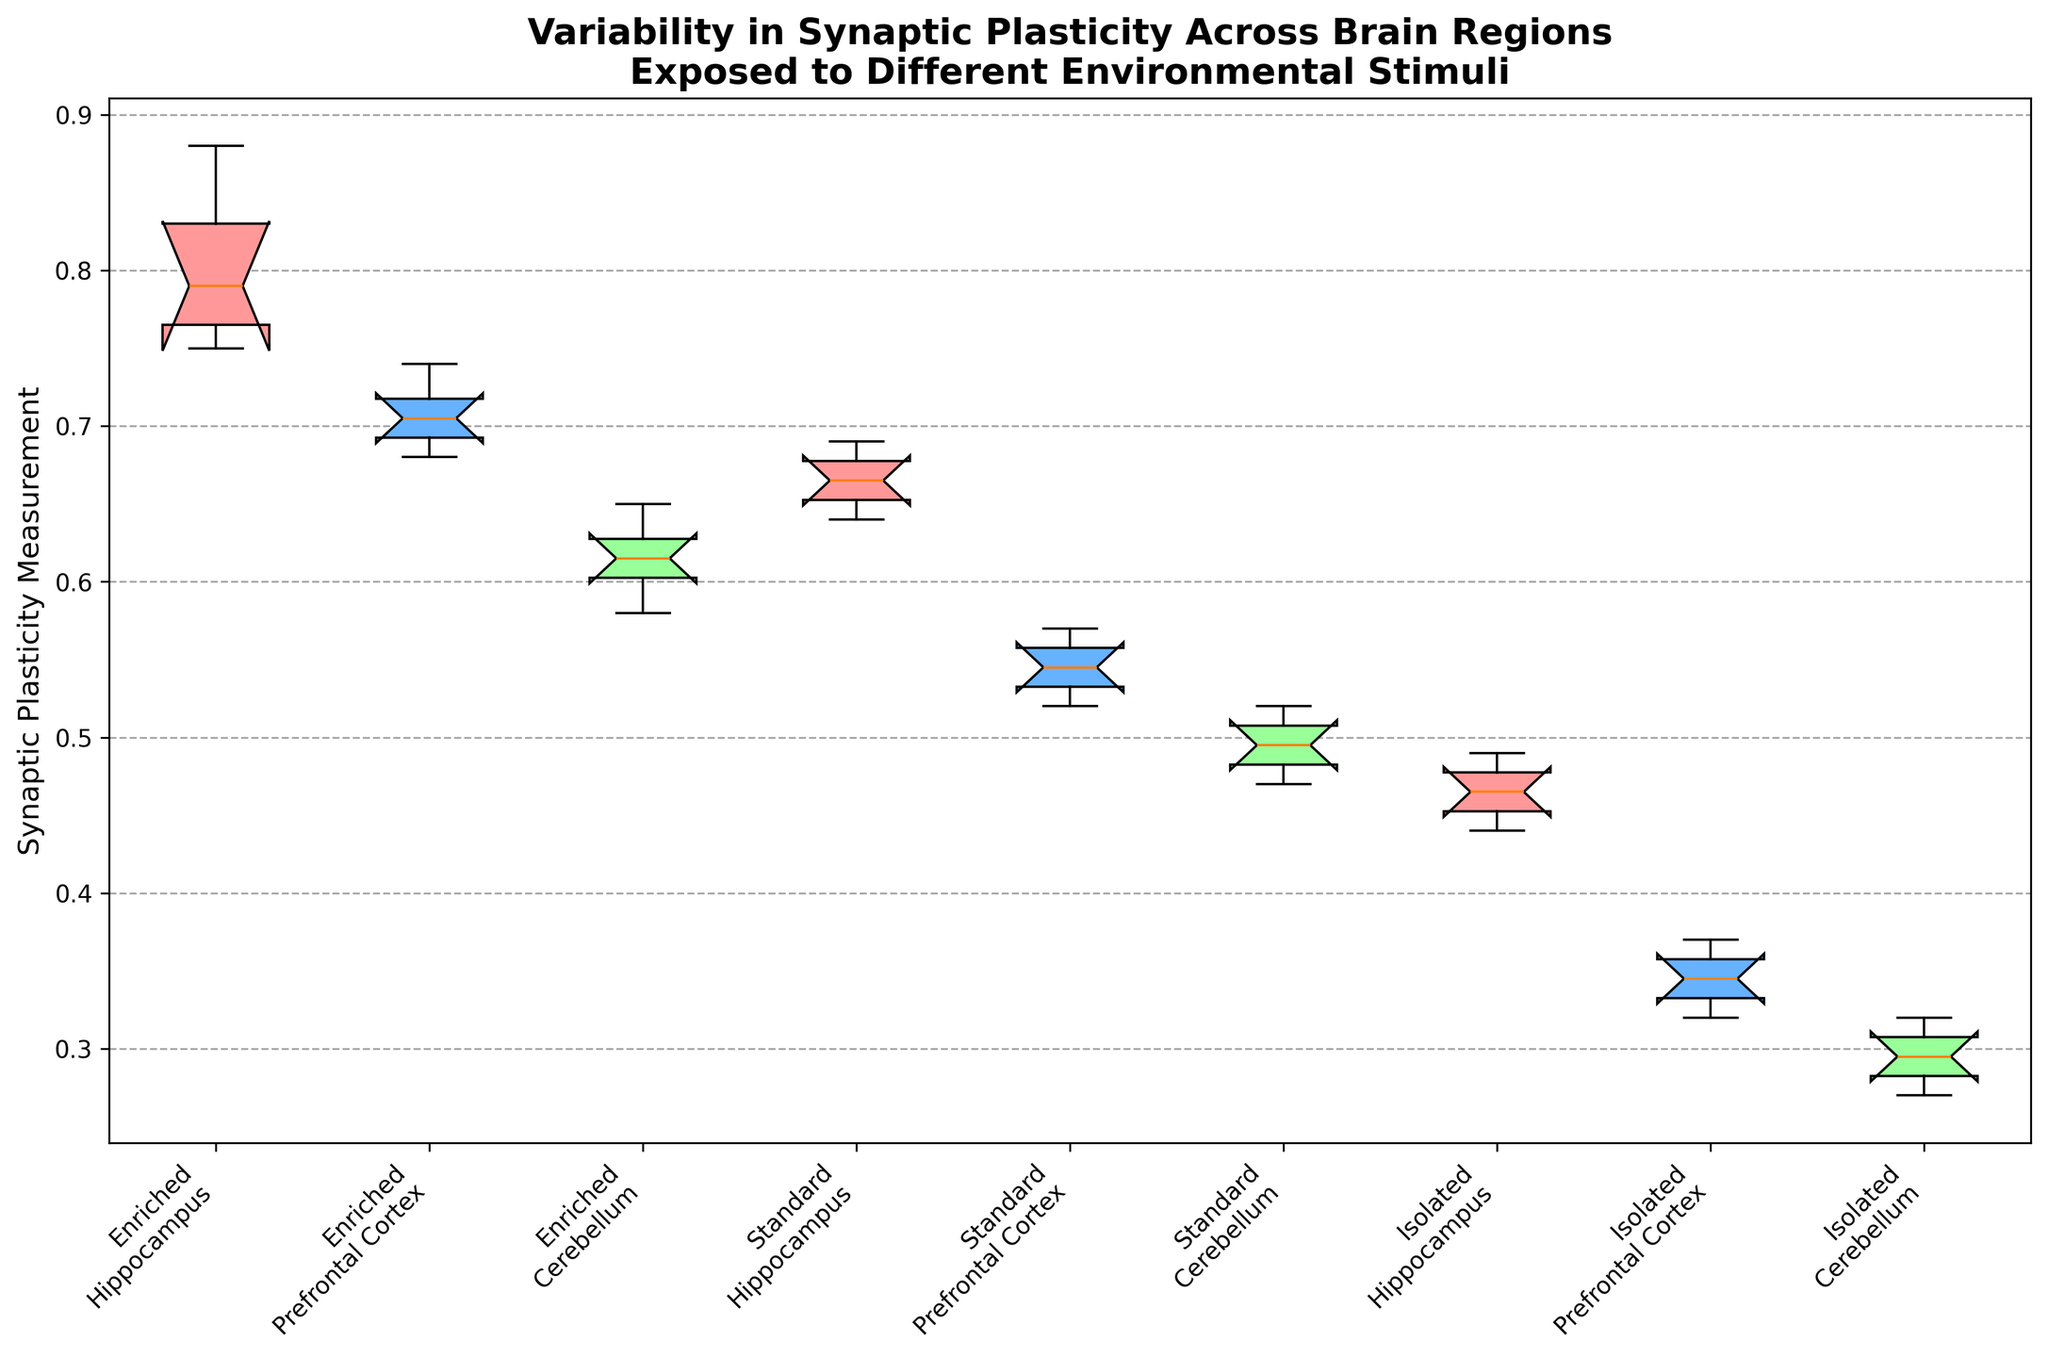Which brain region exposed to an enriched environment shows the highest median synaptic plasticity? The box plot shows the median values within each category as the horizontal line inside the box. For the enriched environment, the hippocampus has the highest median compared to the prefrontal cortex and cerebellum.
Answer: Hippocampus How does the interquartile range (IQR) of synaptic plasticity in the hippocampus compare across the three different environments? The IQR is the range between the first quartile (Q1) and the third quartile (Q3) in a box plot. The enriched hippocampus has a wider IQR compared to the standard and isolated environments. So, the hippocampus in an enriched environment has a higher variability than in standard and isolated conditions.
Answer: Enriched > Standard > Isolated Which environment results in the lowest median synaptic plasticity in the prefrontal cortex? Looking at the medians (the lines inside the boxes) for the prefrontal cortex across different environments, the isolated environment shows the lowest median synaptic plasticity.
Answer: Isolated Compare the variability in synaptic plasticity between the hippocampus and the cerebellum in a standard environment. Variability can be seen by the size of the boxes which represent the IQR. In the standard environment, the hippocampus has a smaller IQR and thus less variability compared to the cerebellum.
Answer: Less in hippocampus than cerebellum How do the upper whiskers (max values, excluding outliers) compare for synaptic plasticity measurements in the hippocampus across all environments? The upper whiskers can be visually compared for each environment. For the hippocampus, the order from highest to lowest upper whisker is: enriched, standard, and isolated environment.
Answer: Enriched > Standard > Isolated What is the median synaptic plasticity measurement for the cerebellum in an isolated environment? The median is represented by the line inside the box for the isolated cerebellum group. Visually, it is around 0.30.
Answer: 0.30 How does the mean synaptic plasticity measurement for the prefrontal cortex in a standard environment compare to its median? The median is represented by the line inside the box, while the mean can be approximated by considering the balance point of all data points within the box plot. In the standard environment for the prefrontal cortex, the median is around 0.54, and the mean appears to be close to the same due to symmetry.
Answer: Close to median What color represents the boxes of synaptic plasticity measurements for the enriched environment? The box plot uses color differentiation. For the enriched environment, the color of the boxes is different shades of red.
Answer: Red 